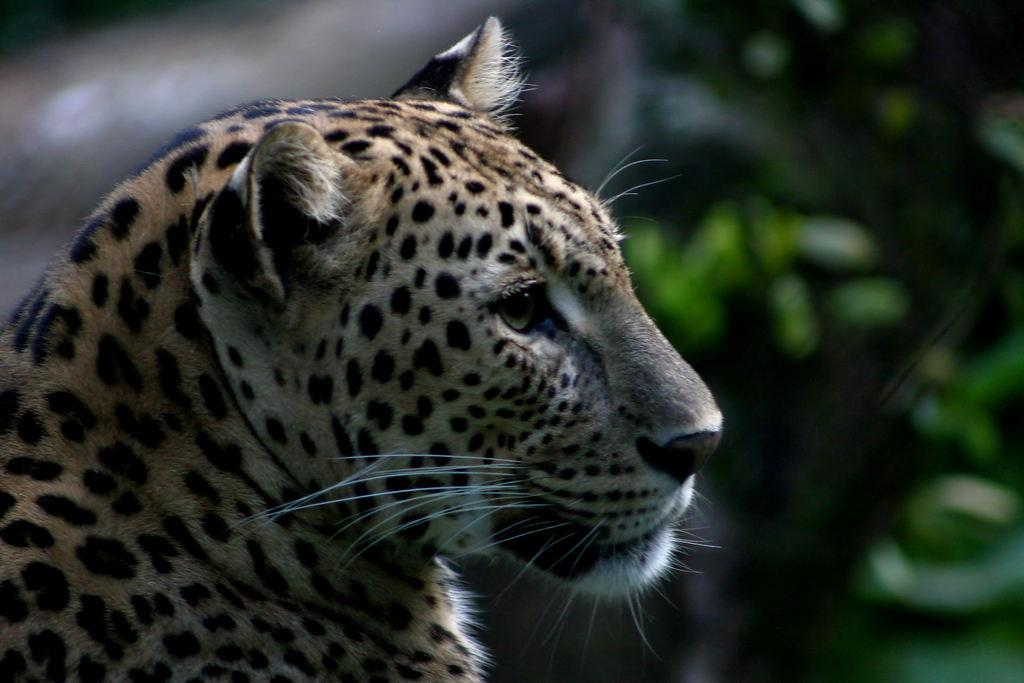What animal is located on the left side of the image? There is a leopard on the left side of the image. How would you describe the background of the image? The background of the image is blurred. Can you see any objects in the background of the image? Yes, there are objects visible in the background of the image. What type of yoke is being used by the leopard in the image? There is no yoke present in the image, as it features a leopard and a blurred background. 